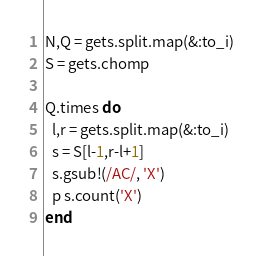Convert code to text. <code><loc_0><loc_0><loc_500><loc_500><_Ruby_>N,Q = gets.split.map(&:to_i)
S = gets.chomp

Q.times do
  l,r = gets.split.map(&:to_i)
  s = S[l-1,r-l+1]
  s.gsub!(/AC/, 'X')
  p s.count('X')
end</code> 